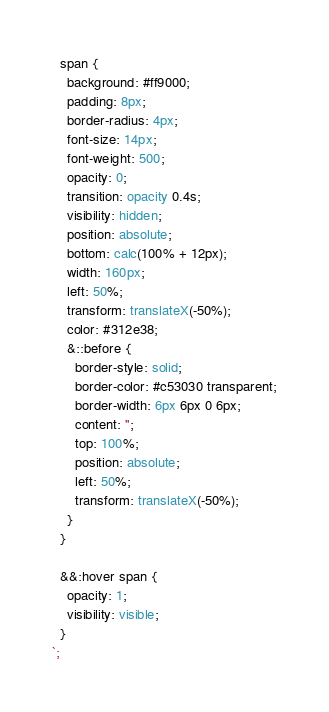<code> <loc_0><loc_0><loc_500><loc_500><_TypeScript_>  span {
    background: #ff9000;
    padding: 8px;
    border-radius: 4px;
    font-size: 14px;
    font-weight: 500;
    opacity: 0;
    transition: opacity 0.4s;
    visibility: hidden;
    position: absolute;
    bottom: calc(100% + 12px);
    width: 160px;
    left: 50%;
    transform: translateX(-50%);
    color: #312e38;
    &::before {
      border-style: solid;
      border-color: #c53030 transparent;
      border-width: 6px 6px 0 6px;
      content: '';
      top: 100%;
      position: absolute;
      left: 50%;
      transform: translateX(-50%);
    }
  }

  &&:hover span {
    opacity: 1;
    visibility: visible;
  }
`;
</code> 